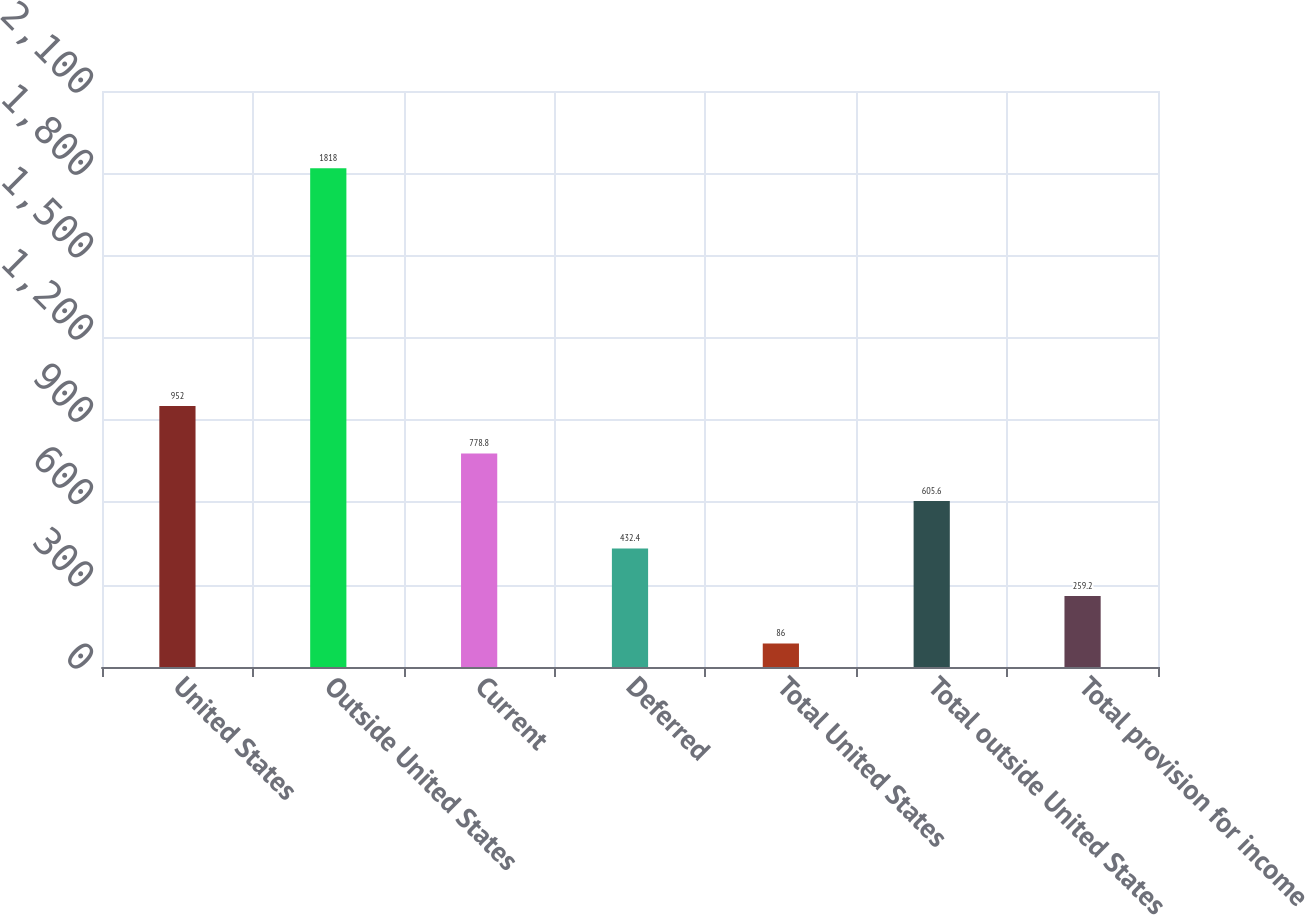Convert chart to OTSL. <chart><loc_0><loc_0><loc_500><loc_500><bar_chart><fcel>United States<fcel>Outside United States<fcel>Current<fcel>Deferred<fcel>Total United States<fcel>Total outside United States<fcel>Total provision for income<nl><fcel>952<fcel>1818<fcel>778.8<fcel>432.4<fcel>86<fcel>605.6<fcel>259.2<nl></chart> 